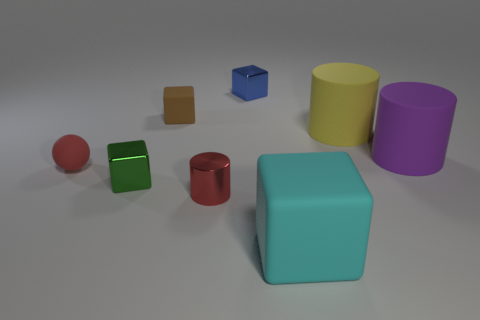There is a small matte thing to the left of the tiny cube that is in front of the large yellow thing; what color is it?
Offer a terse response. Red. What number of tiny metallic things have the same color as the metal cylinder?
Ensure brevity in your answer.  0. Does the tiny cylinder have the same color as the metallic thing that is behind the rubber ball?
Your response must be concise. No. Is the number of red objects less than the number of cyan objects?
Offer a terse response. No. Is the number of red matte things that are on the left side of the purple object greater than the number of cylinders to the right of the blue thing?
Give a very brief answer. No. Is the small sphere made of the same material as the yellow object?
Your answer should be very brief. Yes. There is a rubber block that is to the left of the cyan object; what number of small brown rubber blocks are in front of it?
Offer a very short reply. 0. Is the color of the shiny object that is behind the sphere the same as the small matte cube?
Offer a terse response. No. How many things are green objects or cylinders right of the large cyan object?
Provide a short and direct response. 3. Is the shape of the object that is behind the brown block the same as the small red thing to the right of the small brown block?
Offer a terse response. No. 